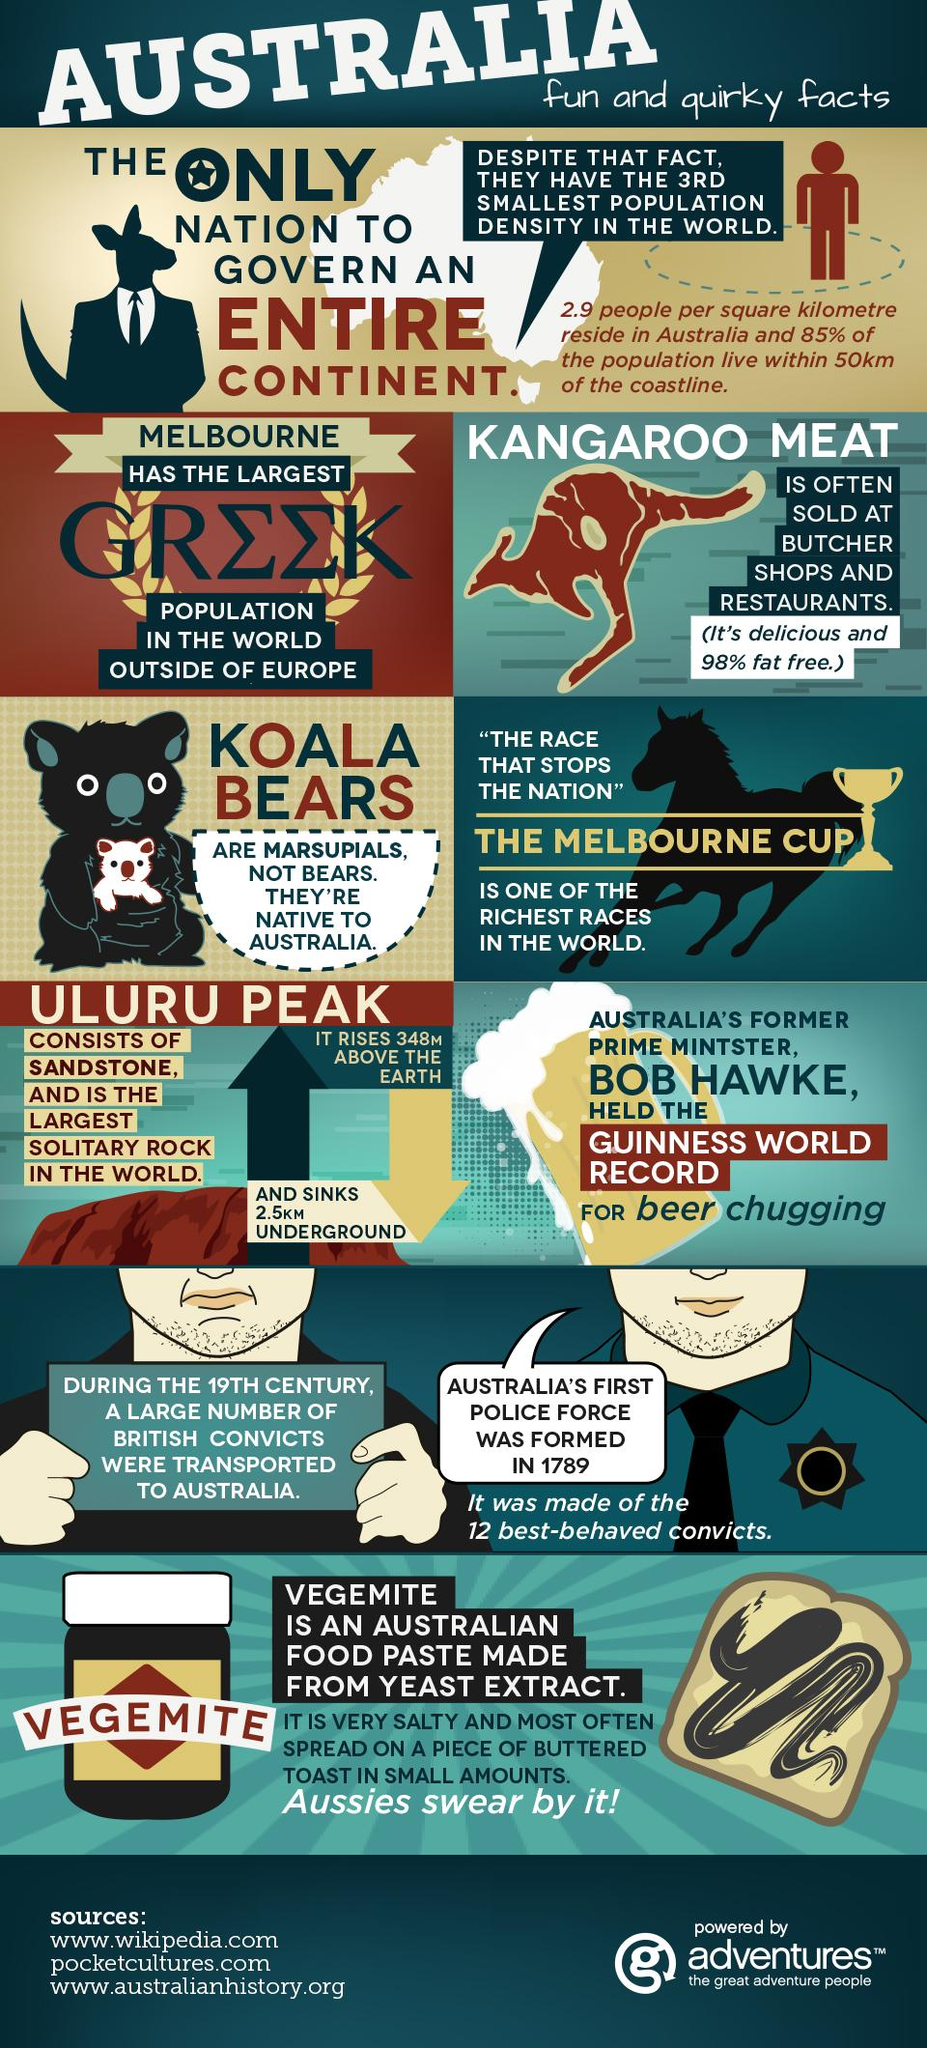Identify some key points in this picture. The Melbourne Cup is known as the richest race of its kind in the world. The animal whose picture is shown as the background of the 'Melbourne cup' block is a horse. Australia's first police force was formed in 1789 with the use of the 12 best-behaved convicts. 